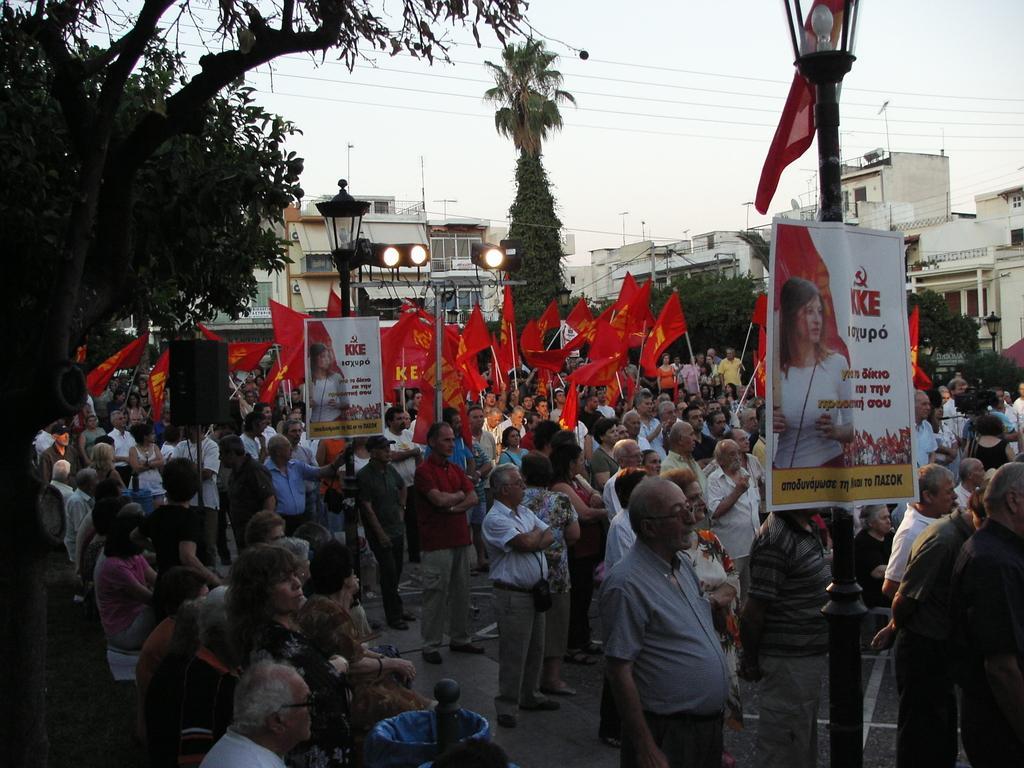In one or two sentences, can you explain what this image depicts? In this image there are group people standing, and some of them are holding flags and some of them are holding some placards. And there are some poles, and on the poles there are some boards, lights, trees, buildings, wires. At the top there is sky, and at the bottom there is walkway. 